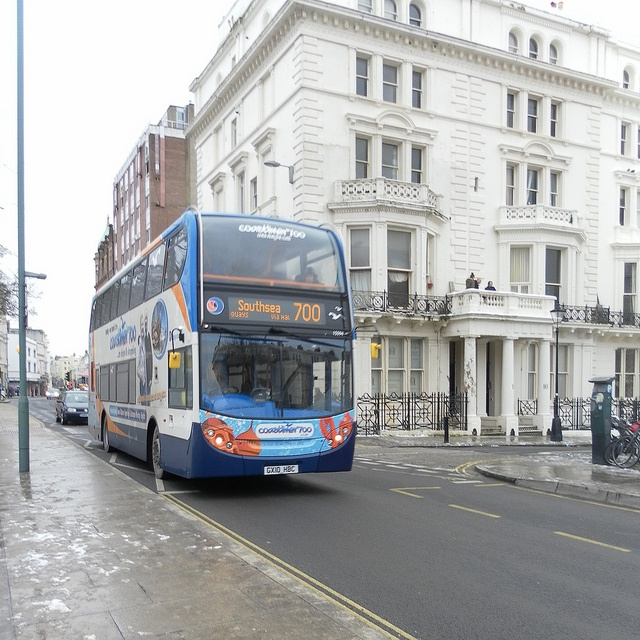Describe the objects in this image and their specific colors. I can see bus in white, gray, darkgray, lightgray, and navy tones, car in white, darkgray, lightblue, gray, and black tones, bicycle in white, gray, black, and darkgray tones, people in white, gray, and black tones, and bicycle in white, gray, and black tones in this image. 